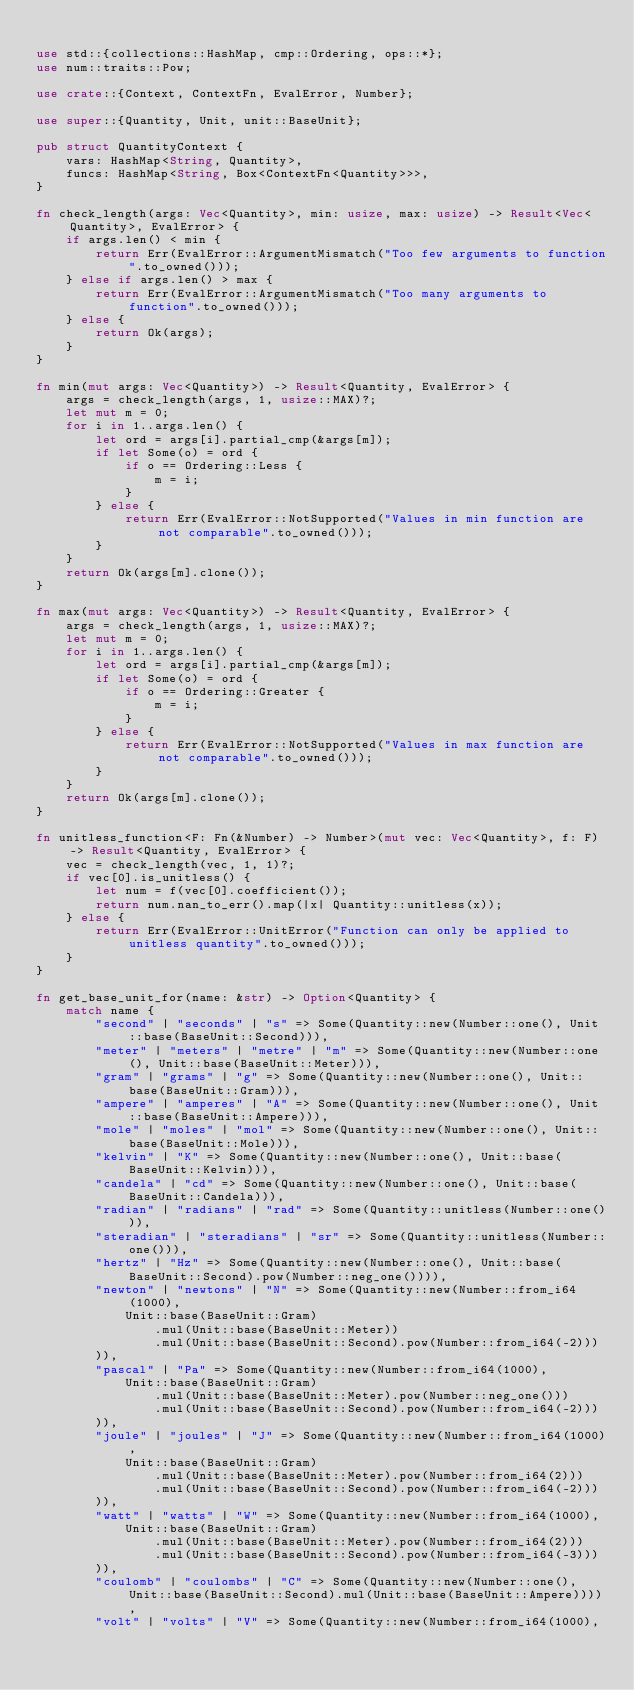<code> <loc_0><loc_0><loc_500><loc_500><_Rust_>
use std::{collections::HashMap, cmp::Ordering, ops::*};
use num::traits::Pow;

use crate::{Context, ContextFn, EvalError, Number};

use super::{Quantity, Unit, unit::BaseUnit};

pub struct QuantityContext {
    vars: HashMap<String, Quantity>,
    funcs: HashMap<String, Box<ContextFn<Quantity>>>,
}

fn check_length(args: Vec<Quantity>, min: usize, max: usize) -> Result<Vec<Quantity>, EvalError> {
    if args.len() < min {
        return Err(EvalError::ArgumentMismatch("Too few arguments to function".to_owned()));
    } else if args.len() > max {
        return Err(EvalError::ArgumentMismatch("Too many arguments to function".to_owned()));
    } else {
        return Ok(args);
    }
}

fn min(mut args: Vec<Quantity>) -> Result<Quantity, EvalError> {
    args = check_length(args, 1, usize::MAX)?;
    let mut m = 0;
    for i in 1..args.len() {
        let ord = args[i].partial_cmp(&args[m]);
        if let Some(o) = ord {
            if o == Ordering::Less {
                m = i;
            }
        } else {
            return Err(EvalError::NotSupported("Values in min function are not comparable".to_owned()));
        }
    }
    return Ok(args[m].clone());
}

fn max(mut args: Vec<Quantity>) -> Result<Quantity, EvalError> {
    args = check_length(args, 1, usize::MAX)?;
    let mut m = 0;
    for i in 1..args.len() {
        let ord = args[i].partial_cmp(&args[m]);
        if let Some(o) = ord {
            if o == Ordering::Greater {
                m = i;
            }
        } else {
            return Err(EvalError::NotSupported("Values in max function are not comparable".to_owned()));
        }
    }
    return Ok(args[m].clone());
}

fn unitless_function<F: Fn(&Number) -> Number>(mut vec: Vec<Quantity>, f: F) -> Result<Quantity, EvalError> {
    vec = check_length(vec, 1, 1)?;
    if vec[0].is_unitless() {
        let num = f(vec[0].coefficient());
        return num.nan_to_err().map(|x| Quantity::unitless(x));
    } else {
        return Err(EvalError::UnitError("Function can only be applied to unitless quantity".to_owned()));
    }
}

fn get_base_unit_for(name: &str) -> Option<Quantity> {
    match name {
        "second" | "seconds" | "s" => Some(Quantity::new(Number::one(), Unit::base(BaseUnit::Second))),
        "meter" | "meters" | "metre" | "m" => Some(Quantity::new(Number::one(), Unit::base(BaseUnit::Meter))),
        "gram" | "grams" | "g" => Some(Quantity::new(Number::one(), Unit::base(BaseUnit::Gram))),
        "ampere" | "amperes" | "A" => Some(Quantity::new(Number::one(), Unit::base(BaseUnit::Ampere))),
        "mole" | "moles" | "mol" => Some(Quantity::new(Number::one(), Unit::base(BaseUnit::Mole))),
        "kelvin" | "K" => Some(Quantity::new(Number::one(), Unit::base(BaseUnit::Kelvin))),
        "candela" | "cd" => Some(Quantity::new(Number::one(), Unit::base(BaseUnit::Candela))),
        "radian" | "radians" | "rad" => Some(Quantity::unitless(Number::one())),
        "steradian" | "steradians" | "sr" => Some(Quantity::unitless(Number::one())),
        "hertz" | "Hz" => Some(Quantity::new(Number::one(), Unit::base(BaseUnit::Second).pow(Number::neg_one()))),
        "newton" | "newtons" | "N" => Some(Quantity::new(Number::from_i64(1000),
            Unit::base(BaseUnit::Gram)
                .mul(Unit::base(BaseUnit::Meter))
                .mul(Unit::base(BaseUnit::Second).pow(Number::from_i64(-2)))
        )),
        "pascal" | "Pa" => Some(Quantity::new(Number::from_i64(1000),
            Unit::base(BaseUnit::Gram)
                .mul(Unit::base(BaseUnit::Meter).pow(Number::neg_one()))
                .mul(Unit::base(BaseUnit::Second).pow(Number::from_i64(-2)))
        )),
        "joule" | "joules" | "J" => Some(Quantity::new(Number::from_i64(1000),
            Unit::base(BaseUnit::Gram)
                .mul(Unit::base(BaseUnit::Meter).pow(Number::from_i64(2)))
                .mul(Unit::base(BaseUnit::Second).pow(Number::from_i64(-2)))
        )),
        "watt" | "watts" | "W" => Some(Quantity::new(Number::from_i64(1000),
            Unit::base(BaseUnit::Gram)
                .mul(Unit::base(BaseUnit::Meter).pow(Number::from_i64(2)))
                .mul(Unit::base(BaseUnit::Second).pow(Number::from_i64(-3)))
        )),
        "coulomb" | "coulombs" | "C" => Some(Quantity::new(Number::one(), Unit::base(BaseUnit::Second).mul(Unit::base(BaseUnit::Ampere)))),
        "volt" | "volts" | "V" => Some(Quantity::new(Number::from_i64(1000),</code> 